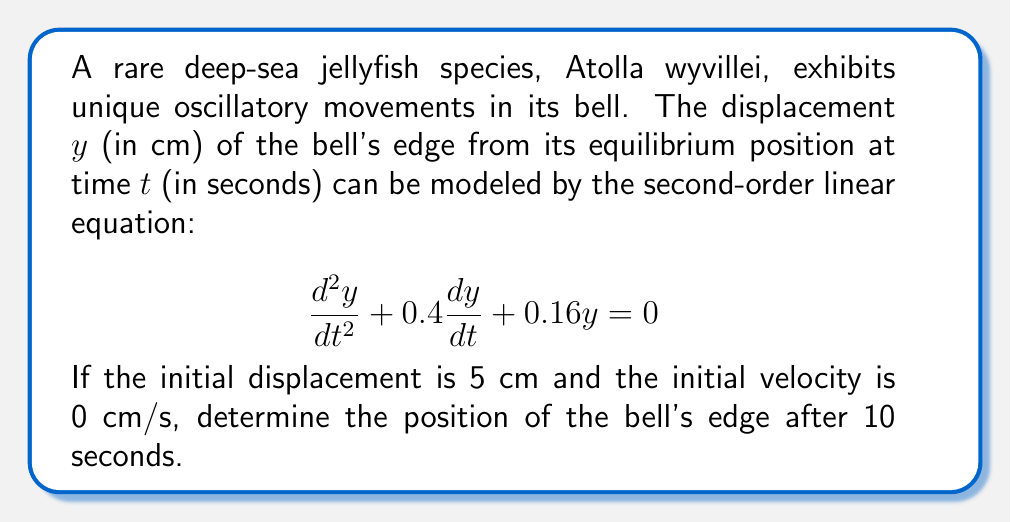Give your solution to this math problem. To solve this problem, we follow these steps:

1) The general solution for a second-order linear equation of the form $\frac{d^2y}{dt^2} + 2\zeta\omega_n\frac{dy}{dt} + \omega_n^2y = 0$ is:

   $y(t) = e^{-\zeta\omega_nt}(A\cos(\omega_dt) + B\sin(\omega_dt))$

   where $\omega_n$ is the natural frequency and $\omega_d$ is the damped frequency.

2) From our equation, we can identify:
   $2\zeta\omega_n = 0.4$ and $\omega_n^2 = 0.16$

3) Solving these:
   $\omega_n = \sqrt{0.16} = 0.4$ rad/s
   $\zeta = \frac{0.4}{2(0.4)} = 0.5$

4) The damped frequency is:
   $\omega_d = \omega_n\sqrt{1-\zeta^2} = 0.4\sqrt{1-0.5^2} \approx 0.3464$ rad/s

5) Now our solution has the form:
   $y(t) = e^{-0.2t}(A\cos(0.3464t) + B\sin(0.3464t))$

6) Using the initial conditions:
   At $t=0$, $y(0) = 5$ cm, so $A = 5$
   At $t=0$, $y'(0) = 0$ cm/s, so $-0.2A + 0.3464B = 0$
   Solving this, we get $B \approx 2.8867$

7) Therefore, our specific solution is:
   $y(t) = e^{-0.2t}(5\cos(0.3464t) + 2.8867\sin(0.3464t))$

8) To find the position at $t=10$ seconds, we simply plug in $t=10$:
   $y(10) = e^{-2}(5\cos(3.464) + 2.8867\sin(3.464))$

9) Calculating this gives us approximately 0.4083 cm.
Answer: The position of the Atolla wyvillei jellyfish's bell edge after 10 seconds is approximately 0.4083 cm from its equilibrium position. 